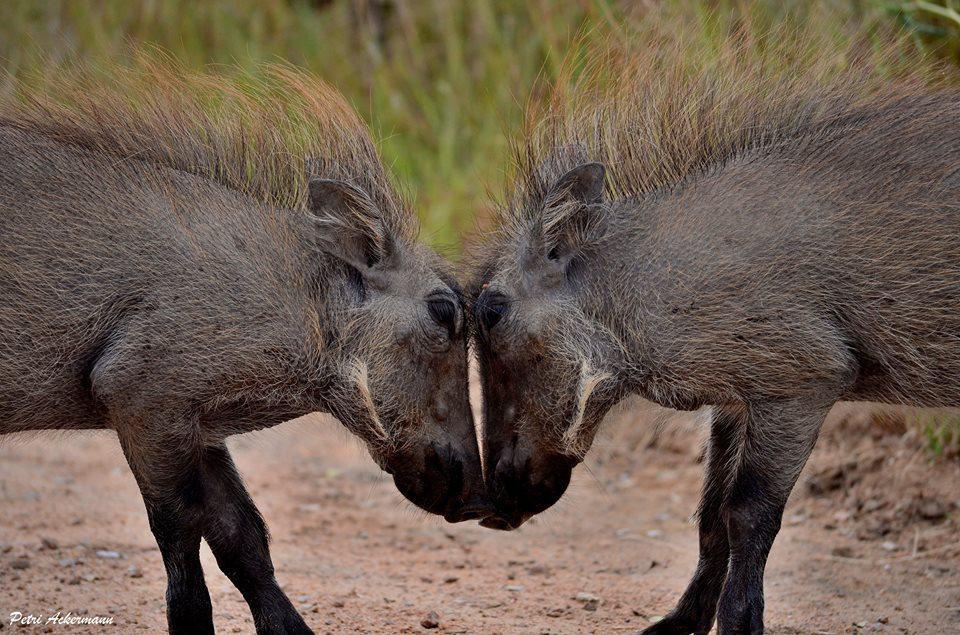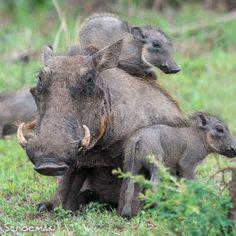The first image is the image on the left, the second image is the image on the right. Given the left and right images, does the statement "An image shows two warthogs face-to-face in the foreground, and no warthogs face-to-face in the background." hold true? Answer yes or no. Yes. The first image is the image on the left, the second image is the image on the right. For the images displayed, is the sentence "Two of the animals in the image on the left are butting heads." factually correct? Answer yes or no. Yes. 